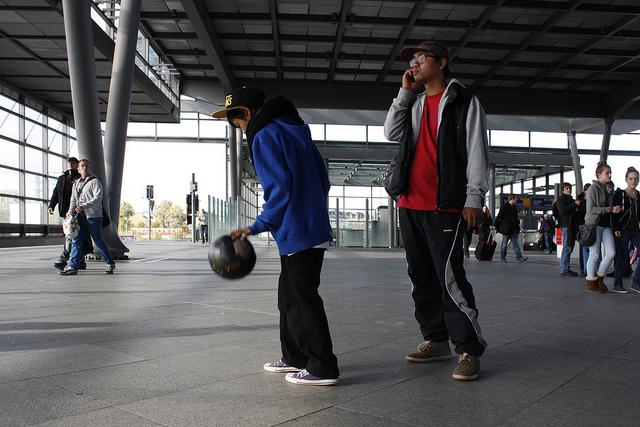What is the boy doing with the black ball? dribbling 